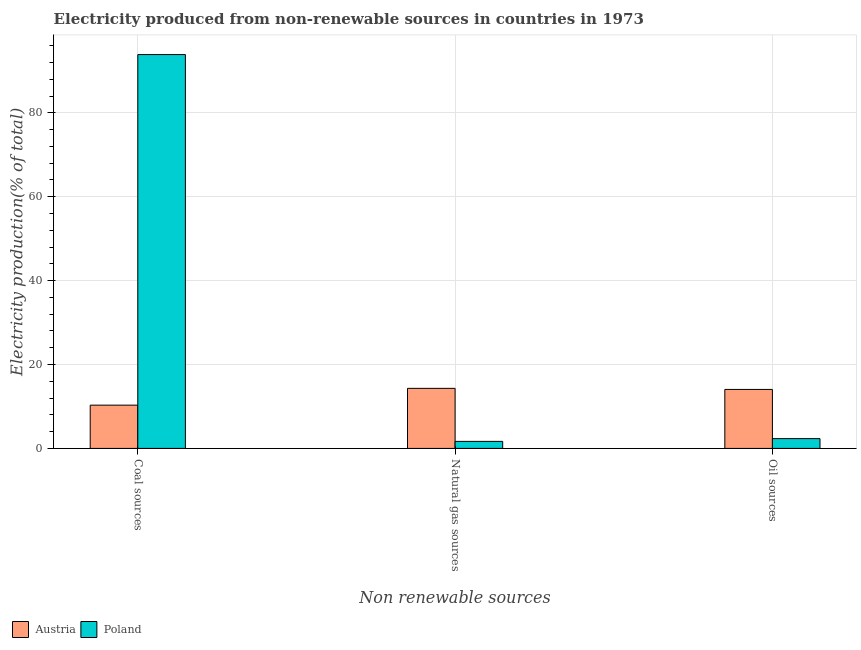How many different coloured bars are there?
Your answer should be very brief. 2. How many groups of bars are there?
Offer a very short reply. 3. Are the number of bars per tick equal to the number of legend labels?
Provide a short and direct response. Yes. How many bars are there on the 2nd tick from the right?
Offer a very short reply. 2. What is the label of the 3rd group of bars from the left?
Your answer should be compact. Oil sources. What is the percentage of electricity produced by coal in Poland?
Your answer should be very brief. 93.9. Across all countries, what is the maximum percentage of electricity produced by oil sources?
Give a very brief answer. 14.06. Across all countries, what is the minimum percentage of electricity produced by coal?
Offer a very short reply. 10.32. In which country was the percentage of electricity produced by coal maximum?
Ensure brevity in your answer.  Poland. What is the total percentage of electricity produced by oil sources in the graph?
Offer a terse response. 16.4. What is the difference between the percentage of electricity produced by coal in Austria and that in Poland?
Your response must be concise. -83.58. What is the difference between the percentage of electricity produced by oil sources in Austria and the percentage of electricity produced by natural gas in Poland?
Ensure brevity in your answer.  12.39. What is the average percentage of electricity produced by oil sources per country?
Your answer should be compact. 8.2. What is the difference between the percentage of electricity produced by coal and percentage of electricity produced by oil sources in Austria?
Keep it short and to the point. -3.75. In how many countries, is the percentage of electricity produced by natural gas greater than 92 %?
Provide a short and direct response. 0. What is the ratio of the percentage of electricity produced by coal in Poland to that in Austria?
Make the answer very short. 9.1. Is the percentage of electricity produced by oil sources in Poland less than that in Austria?
Make the answer very short. Yes. Is the difference between the percentage of electricity produced by coal in Poland and Austria greater than the difference between the percentage of electricity produced by oil sources in Poland and Austria?
Your answer should be compact. Yes. What is the difference between the highest and the second highest percentage of electricity produced by oil sources?
Keep it short and to the point. 11.73. What is the difference between the highest and the lowest percentage of electricity produced by oil sources?
Your response must be concise. 11.73. What does the 2nd bar from the right in Natural gas sources represents?
Your response must be concise. Austria. Is it the case that in every country, the sum of the percentage of electricity produced by coal and percentage of electricity produced by natural gas is greater than the percentage of electricity produced by oil sources?
Provide a succinct answer. Yes. How many countries are there in the graph?
Keep it short and to the point. 2. Are the values on the major ticks of Y-axis written in scientific E-notation?
Make the answer very short. No. Does the graph contain grids?
Make the answer very short. Yes. How are the legend labels stacked?
Keep it short and to the point. Horizontal. What is the title of the graph?
Make the answer very short. Electricity produced from non-renewable sources in countries in 1973. What is the label or title of the X-axis?
Offer a very short reply. Non renewable sources. What is the Electricity production(% of total) in Austria in Coal sources?
Your answer should be very brief. 10.32. What is the Electricity production(% of total) in Poland in Coal sources?
Ensure brevity in your answer.  93.9. What is the Electricity production(% of total) in Austria in Natural gas sources?
Make the answer very short. 14.32. What is the Electricity production(% of total) of Poland in Natural gas sources?
Keep it short and to the point. 1.68. What is the Electricity production(% of total) of Austria in Oil sources?
Provide a succinct answer. 14.06. What is the Electricity production(% of total) of Poland in Oil sources?
Provide a short and direct response. 2.34. Across all Non renewable sources, what is the maximum Electricity production(% of total) in Austria?
Your answer should be very brief. 14.32. Across all Non renewable sources, what is the maximum Electricity production(% of total) in Poland?
Your response must be concise. 93.9. Across all Non renewable sources, what is the minimum Electricity production(% of total) in Austria?
Give a very brief answer. 10.32. Across all Non renewable sources, what is the minimum Electricity production(% of total) in Poland?
Ensure brevity in your answer.  1.68. What is the total Electricity production(% of total) of Austria in the graph?
Offer a terse response. 38.7. What is the total Electricity production(% of total) of Poland in the graph?
Your answer should be compact. 97.91. What is the difference between the Electricity production(% of total) in Austria in Coal sources and that in Natural gas sources?
Keep it short and to the point. -4. What is the difference between the Electricity production(% of total) of Poland in Coal sources and that in Natural gas sources?
Provide a succinct answer. 92.22. What is the difference between the Electricity production(% of total) of Austria in Coal sources and that in Oil sources?
Your response must be concise. -3.75. What is the difference between the Electricity production(% of total) in Poland in Coal sources and that in Oil sources?
Offer a very short reply. 91.56. What is the difference between the Electricity production(% of total) of Austria in Natural gas sources and that in Oil sources?
Provide a short and direct response. 0.26. What is the difference between the Electricity production(% of total) of Poland in Natural gas sources and that in Oil sources?
Keep it short and to the point. -0.66. What is the difference between the Electricity production(% of total) of Austria in Coal sources and the Electricity production(% of total) of Poland in Natural gas sources?
Provide a short and direct response. 8.64. What is the difference between the Electricity production(% of total) in Austria in Coal sources and the Electricity production(% of total) in Poland in Oil sources?
Give a very brief answer. 7.98. What is the difference between the Electricity production(% of total) in Austria in Natural gas sources and the Electricity production(% of total) in Poland in Oil sources?
Offer a very short reply. 11.98. What is the average Electricity production(% of total) in Austria per Non renewable sources?
Ensure brevity in your answer.  12.9. What is the average Electricity production(% of total) in Poland per Non renewable sources?
Your answer should be compact. 32.64. What is the difference between the Electricity production(% of total) in Austria and Electricity production(% of total) in Poland in Coal sources?
Provide a succinct answer. -83.58. What is the difference between the Electricity production(% of total) of Austria and Electricity production(% of total) of Poland in Natural gas sources?
Your response must be concise. 12.64. What is the difference between the Electricity production(% of total) of Austria and Electricity production(% of total) of Poland in Oil sources?
Give a very brief answer. 11.73. What is the ratio of the Electricity production(% of total) of Austria in Coal sources to that in Natural gas sources?
Give a very brief answer. 0.72. What is the ratio of the Electricity production(% of total) of Poland in Coal sources to that in Natural gas sources?
Give a very brief answer. 55.96. What is the ratio of the Electricity production(% of total) in Austria in Coal sources to that in Oil sources?
Your answer should be compact. 0.73. What is the ratio of the Electricity production(% of total) of Poland in Coal sources to that in Oil sources?
Your answer should be very brief. 40.18. What is the ratio of the Electricity production(% of total) in Austria in Natural gas sources to that in Oil sources?
Your response must be concise. 1.02. What is the ratio of the Electricity production(% of total) in Poland in Natural gas sources to that in Oil sources?
Give a very brief answer. 0.72. What is the difference between the highest and the second highest Electricity production(% of total) in Austria?
Provide a short and direct response. 0.26. What is the difference between the highest and the second highest Electricity production(% of total) in Poland?
Give a very brief answer. 91.56. What is the difference between the highest and the lowest Electricity production(% of total) of Austria?
Offer a very short reply. 4. What is the difference between the highest and the lowest Electricity production(% of total) in Poland?
Offer a terse response. 92.22. 